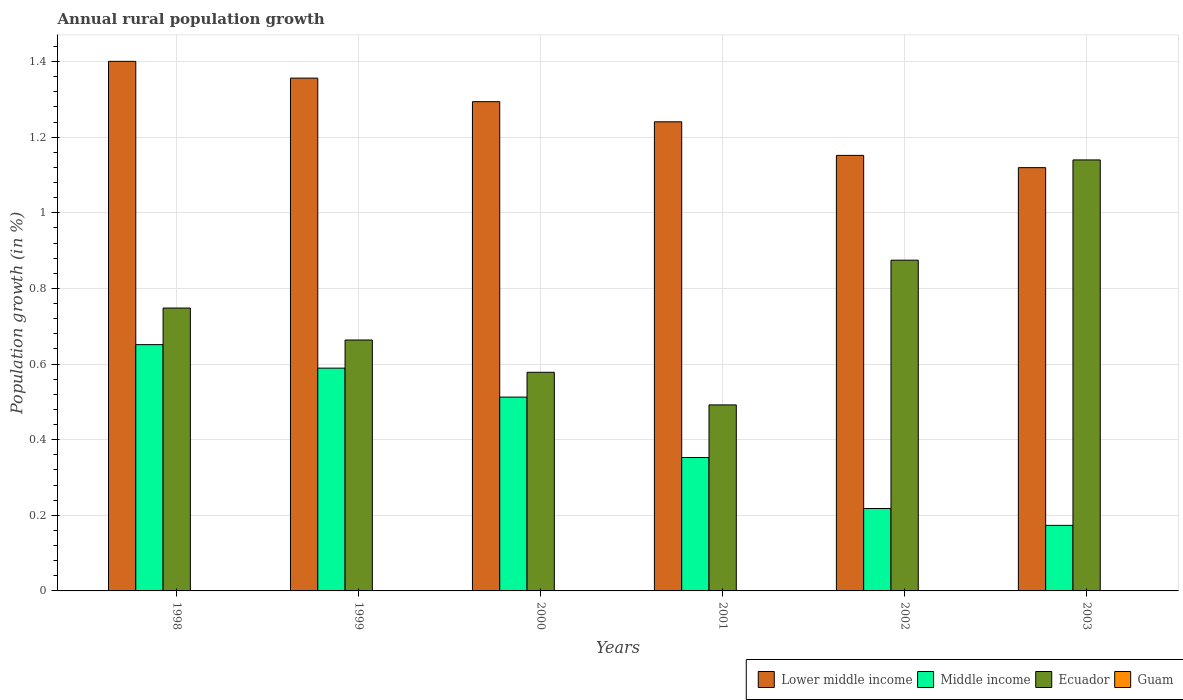How many groups of bars are there?
Ensure brevity in your answer.  6. How many bars are there on the 1st tick from the right?
Provide a short and direct response. 3. Across all years, what is the maximum percentage of rural population growth in Ecuador?
Ensure brevity in your answer.  1.14. Across all years, what is the minimum percentage of rural population growth in Middle income?
Your answer should be very brief. 0.17. In which year was the percentage of rural population growth in Middle income maximum?
Your answer should be very brief. 1998. What is the difference between the percentage of rural population growth in Ecuador in 1998 and that in 2000?
Offer a terse response. 0.17. What is the difference between the percentage of rural population growth in Lower middle income in 1998 and the percentage of rural population growth in Guam in 2001?
Your answer should be compact. 1.4. What is the average percentage of rural population growth in Guam per year?
Provide a short and direct response. 0. In the year 1999, what is the difference between the percentage of rural population growth in Lower middle income and percentage of rural population growth in Ecuador?
Your answer should be compact. 0.69. What is the ratio of the percentage of rural population growth in Ecuador in 1998 to that in 2002?
Provide a succinct answer. 0.86. What is the difference between the highest and the second highest percentage of rural population growth in Lower middle income?
Provide a short and direct response. 0.04. What is the difference between the highest and the lowest percentage of rural population growth in Middle income?
Provide a short and direct response. 0.48. In how many years, is the percentage of rural population growth in Lower middle income greater than the average percentage of rural population growth in Lower middle income taken over all years?
Your answer should be compact. 3. Is the sum of the percentage of rural population growth in Middle income in 1999 and 2002 greater than the maximum percentage of rural population growth in Guam across all years?
Provide a succinct answer. Yes. Is it the case that in every year, the sum of the percentage of rural population growth in Ecuador and percentage of rural population growth in Guam is greater than the sum of percentage of rural population growth in Lower middle income and percentage of rural population growth in Middle income?
Provide a succinct answer. No. Is it the case that in every year, the sum of the percentage of rural population growth in Guam and percentage of rural population growth in Middle income is greater than the percentage of rural population growth in Lower middle income?
Provide a short and direct response. No. Are all the bars in the graph horizontal?
Give a very brief answer. No. What is the difference between two consecutive major ticks on the Y-axis?
Give a very brief answer. 0.2. Where does the legend appear in the graph?
Your answer should be compact. Bottom right. How many legend labels are there?
Offer a very short reply. 4. What is the title of the graph?
Ensure brevity in your answer.  Annual rural population growth. Does "Virgin Islands" appear as one of the legend labels in the graph?
Offer a terse response. No. What is the label or title of the Y-axis?
Keep it short and to the point. Population growth (in %). What is the Population growth (in %) of Lower middle income in 1998?
Your answer should be compact. 1.4. What is the Population growth (in %) in Middle income in 1998?
Your answer should be very brief. 0.65. What is the Population growth (in %) in Ecuador in 1998?
Provide a short and direct response. 0.75. What is the Population growth (in %) of Lower middle income in 1999?
Offer a very short reply. 1.36. What is the Population growth (in %) of Middle income in 1999?
Your answer should be compact. 0.59. What is the Population growth (in %) in Ecuador in 1999?
Provide a succinct answer. 0.66. What is the Population growth (in %) of Guam in 1999?
Keep it short and to the point. 0. What is the Population growth (in %) of Lower middle income in 2000?
Give a very brief answer. 1.29. What is the Population growth (in %) in Middle income in 2000?
Give a very brief answer. 0.51. What is the Population growth (in %) in Ecuador in 2000?
Offer a terse response. 0.58. What is the Population growth (in %) of Lower middle income in 2001?
Your answer should be very brief. 1.24. What is the Population growth (in %) of Middle income in 2001?
Make the answer very short. 0.35. What is the Population growth (in %) of Ecuador in 2001?
Give a very brief answer. 0.49. What is the Population growth (in %) of Lower middle income in 2002?
Your answer should be compact. 1.15. What is the Population growth (in %) in Middle income in 2002?
Offer a very short reply. 0.22. What is the Population growth (in %) in Ecuador in 2002?
Make the answer very short. 0.87. What is the Population growth (in %) in Guam in 2002?
Make the answer very short. 0. What is the Population growth (in %) of Lower middle income in 2003?
Offer a terse response. 1.12. What is the Population growth (in %) in Middle income in 2003?
Ensure brevity in your answer.  0.17. What is the Population growth (in %) of Ecuador in 2003?
Provide a succinct answer. 1.14. Across all years, what is the maximum Population growth (in %) of Lower middle income?
Provide a short and direct response. 1.4. Across all years, what is the maximum Population growth (in %) in Middle income?
Provide a short and direct response. 0.65. Across all years, what is the maximum Population growth (in %) in Ecuador?
Make the answer very short. 1.14. Across all years, what is the minimum Population growth (in %) of Lower middle income?
Your response must be concise. 1.12. Across all years, what is the minimum Population growth (in %) in Middle income?
Offer a terse response. 0.17. Across all years, what is the minimum Population growth (in %) of Ecuador?
Your answer should be compact. 0.49. What is the total Population growth (in %) in Lower middle income in the graph?
Offer a terse response. 7.56. What is the total Population growth (in %) in Middle income in the graph?
Keep it short and to the point. 2.5. What is the total Population growth (in %) of Ecuador in the graph?
Offer a very short reply. 4.5. What is the total Population growth (in %) of Guam in the graph?
Offer a terse response. 0. What is the difference between the Population growth (in %) in Lower middle income in 1998 and that in 1999?
Ensure brevity in your answer.  0.04. What is the difference between the Population growth (in %) in Middle income in 1998 and that in 1999?
Your response must be concise. 0.06. What is the difference between the Population growth (in %) of Ecuador in 1998 and that in 1999?
Keep it short and to the point. 0.08. What is the difference between the Population growth (in %) of Lower middle income in 1998 and that in 2000?
Ensure brevity in your answer.  0.11. What is the difference between the Population growth (in %) of Middle income in 1998 and that in 2000?
Give a very brief answer. 0.14. What is the difference between the Population growth (in %) in Ecuador in 1998 and that in 2000?
Offer a terse response. 0.17. What is the difference between the Population growth (in %) of Lower middle income in 1998 and that in 2001?
Your response must be concise. 0.16. What is the difference between the Population growth (in %) in Middle income in 1998 and that in 2001?
Offer a terse response. 0.3. What is the difference between the Population growth (in %) in Ecuador in 1998 and that in 2001?
Your answer should be very brief. 0.26. What is the difference between the Population growth (in %) in Lower middle income in 1998 and that in 2002?
Give a very brief answer. 0.25. What is the difference between the Population growth (in %) in Middle income in 1998 and that in 2002?
Your response must be concise. 0.43. What is the difference between the Population growth (in %) in Ecuador in 1998 and that in 2002?
Keep it short and to the point. -0.13. What is the difference between the Population growth (in %) in Lower middle income in 1998 and that in 2003?
Offer a terse response. 0.28. What is the difference between the Population growth (in %) of Middle income in 1998 and that in 2003?
Your answer should be compact. 0.48. What is the difference between the Population growth (in %) of Ecuador in 1998 and that in 2003?
Your answer should be compact. -0.39. What is the difference between the Population growth (in %) of Lower middle income in 1999 and that in 2000?
Offer a terse response. 0.06. What is the difference between the Population growth (in %) of Middle income in 1999 and that in 2000?
Your response must be concise. 0.08. What is the difference between the Population growth (in %) in Ecuador in 1999 and that in 2000?
Give a very brief answer. 0.09. What is the difference between the Population growth (in %) of Lower middle income in 1999 and that in 2001?
Ensure brevity in your answer.  0.12. What is the difference between the Population growth (in %) in Middle income in 1999 and that in 2001?
Offer a terse response. 0.24. What is the difference between the Population growth (in %) of Ecuador in 1999 and that in 2001?
Offer a very short reply. 0.17. What is the difference between the Population growth (in %) of Lower middle income in 1999 and that in 2002?
Give a very brief answer. 0.2. What is the difference between the Population growth (in %) of Middle income in 1999 and that in 2002?
Offer a very short reply. 0.37. What is the difference between the Population growth (in %) in Ecuador in 1999 and that in 2002?
Offer a very short reply. -0.21. What is the difference between the Population growth (in %) in Lower middle income in 1999 and that in 2003?
Keep it short and to the point. 0.24. What is the difference between the Population growth (in %) of Middle income in 1999 and that in 2003?
Keep it short and to the point. 0.42. What is the difference between the Population growth (in %) of Ecuador in 1999 and that in 2003?
Keep it short and to the point. -0.48. What is the difference between the Population growth (in %) in Lower middle income in 2000 and that in 2001?
Your answer should be very brief. 0.05. What is the difference between the Population growth (in %) in Middle income in 2000 and that in 2001?
Provide a succinct answer. 0.16. What is the difference between the Population growth (in %) in Ecuador in 2000 and that in 2001?
Your answer should be compact. 0.09. What is the difference between the Population growth (in %) of Lower middle income in 2000 and that in 2002?
Your answer should be very brief. 0.14. What is the difference between the Population growth (in %) in Middle income in 2000 and that in 2002?
Make the answer very short. 0.29. What is the difference between the Population growth (in %) in Ecuador in 2000 and that in 2002?
Offer a terse response. -0.3. What is the difference between the Population growth (in %) in Lower middle income in 2000 and that in 2003?
Offer a terse response. 0.17. What is the difference between the Population growth (in %) of Middle income in 2000 and that in 2003?
Your response must be concise. 0.34. What is the difference between the Population growth (in %) of Ecuador in 2000 and that in 2003?
Make the answer very short. -0.56. What is the difference between the Population growth (in %) of Lower middle income in 2001 and that in 2002?
Make the answer very short. 0.09. What is the difference between the Population growth (in %) of Middle income in 2001 and that in 2002?
Your response must be concise. 0.14. What is the difference between the Population growth (in %) in Ecuador in 2001 and that in 2002?
Your answer should be compact. -0.38. What is the difference between the Population growth (in %) in Lower middle income in 2001 and that in 2003?
Offer a very short reply. 0.12. What is the difference between the Population growth (in %) in Middle income in 2001 and that in 2003?
Ensure brevity in your answer.  0.18. What is the difference between the Population growth (in %) in Ecuador in 2001 and that in 2003?
Offer a terse response. -0.65. What is the difference between the Population growth (in %) of Lower middle income in 2002 and that in 2003?
Offer a terse response. 0.03. What is the difference between the Population growth (in %) in Middle income in 2002 and that in 2003?
Your answer should be very brief. 0.04. What is the difference between the Population growth (in %) in Ecuador in 2002 and that in 2003?
Keep it short and to the point. -0.27. What is the difference between the Population growth (in %) of Lower middle income in 1998 and the Population growth (in %) of Middle income in 1999?
Make the answer very short. 0.81. What is the difference between the Population growth (in %) in Lower middle income in 1998 and the Population growth (in %) in Ecuador in 1999?
Ensure brevity in your answer.  0.74. What is the difference between the Population growth (in %) of Middle income in 1998 and the Population growth (in %) of Ecuador in 1999?
Your response must be concise. -0.01. What is the difference between the Population growth (in %) in Lower middle income in 1998 and the Population growth (in %) in Middle income in 2000?
Your response must be concise. 0.89. What is the difference between the Population growth (in %) in Lower middle income in 1998 and the Population growth (in %) in Ecuador in 2000?
Provide a short and direct response. 0.82. What is the difference between the Population growth (in %) of Middle income in 1998 and the Population growth (in %) of Ecuador in 2000?
Your response must be concise. 0.07. What is the difference between the Population growth (in %) in Lower middle income in 1998 and the Population growth (in %) in Middle income in 2001?
Keep it short and to the point. 1.05. What is the difference between the Population growth (in %) in Lower middle income in 1998 and the Population growth (in %) in Ecuador in 2001?
Your answer should be compact. 0.91. What is the difference between the Population growth (in %) of Middle income in 1998 and the Population growth (in %) of Ecuador in 2001?
Offer a terse response. 0.16. What is the difference between the Population growth (in %) in Lower middle income in 1998 and the Population growth (in %) in Middle income in 2002?
Provide a succinct answer. 1.18. What is the difference between the Population growth (in %) in Lower middle income in 1998 and the Population growth (in %) in Ecuador in 2002?
Your response must be concise. 0.53. What is the difference between the Population growth (in %) of Middle income in 1998 and the Population growth (in %) of Ecuador in 2002?
Provide a short and direct response. -0.22. What is the difference between the Population growth (in %) of Lower middle income in 1998 and the Population growth (in %) of Middle income in 2003?
Offer a terse response. 1.23. What is the difference between the Population growth (in %) of Lower middle income in 1998 and the Population growth (in %) of Ecuador in 2003?
Your answer should be compact. 0.26. What is the difference between the Population growth (in %) of Middle income in 1998 and the Population growth (in %) of Ecuador in 2003?
Provide a succinct answer. -0.49. What is the difference between the Population growth (in %) of Lower middle income in 1999 and the Population growth (in %) of Middle income in 2000?
Make the answer very short. 0.84. What is the difference between the Population growth (in %) in Lower middle income in 1999 and the Population growth (in %) in Ecuador in 2000?
Provide a succinct answer. 0.78. What is the difference between the Population growth (in %) in Middle income in 1999 and the Population growth (in %) in Ecuador in 2000?
Your answer should be very brief. 0.01. What is the difference between the Population growth (in %) of Lower middle income in 1999 and the Population growth (in %) of Middle income in 2001?
Offer a very short reply. 1. What is the difference between the Population growth (in %) in Lower middle income in 1999 and the Population growth (in %) in Ecuador in 2001?
Offer a very short reply. 0.86. What is the difference between the Population growth (in %) in Middle income in 1999 and the Population growth (in %) in Ecuador in 2001?
Make the answer very short. 0.1. What is the difference between the Population growth (in %) of Lower middle income in 1999 and the Population growth (in %) of Middle income in 2002?
Give a very brief answer. 1.14. What is the difference between the Population growth (in %) of Lower middle income in 1999 and the Population growth (in %) of Ecuador in 2002?
Provide a succinct answer. 0.48. What is the difference between the Population growth (in %) of Middle income in 1999 and the Population growth (in %) of Ecuador in 2002?
Keep it short and to the point. -0.29. What is the difference between the Population growth (in %) of Lower middle income in 1999 and the Population growth (in %) of Middle income in 2003?
Provide a short and direct response. 1.18. What is the difference between the Population growth (in %) in Lower middle income in 1999 and the Population growth (in %) in Ecuador in 2003?
Your response must be concise. 0.22. What is the difference between the Population growth (in %) in Middle income in 1999 and the Population growth (in %) in Ecuador in 2003?
Your answer should be compact. -0.55. What is the difference between the Population growth (in %) of Lower middle income in 2000 and the Population growth (in %) of Ecuador in 2001?
Your response must be concise. 0.8. What is the difference between the Population growth (in %) in Middle income in 2000 and the Population growth (in %) in Ecuador in 2001?
Provide a succinct answer. 0.02. What is the difference between the Population growth (in %) of Lower middle income in 2000 and the Population growth (in %) of Middle income in 2002?
Keep it short and to the point. 1.08. What is the difference between the Population growth (in %) of Lower middle income in 2000 and the Population growth (in %) of Ecuador in 2002?
Provide a short and direct response. 0.42. What is the difference between the Population growth (in %) of Middle income in 2000 and the Population growth (in %) of Ecuador in 2002?
Your answer should be compact. -0.36. What is the difference between the Population growth (in %) in Lower middle income in 2000 and the Population growth (in %) in Middle income in 2003?
Provide a short and direct response. 1.12. What is the difference between the Population growth (in %) in Lower middle income in 2000 and the Population growth (in %) in Ecuador in 2003?
Keep it short and to the point. 0.15. What is the difference between the Population growth (in %) of Middle income in 2000 and the Population growth (in %) of Ecuador in 2003?
Your answer should be very brief. -0.63. What is the difference between the Population growth (in %) of Lower middle income in 2001 and the Population growth (in %) of Middle income in 2002?
Your answer should be very brief. 1.02. What is the difference between the Population growth (in %) in Lower middle income in 2001 and the Population growth (in %) in Ecuador in 2002?
Keep it short and to the point. 0.37. What is the difference between the Population growth (in %) in Middle income in 2001 and the Population growth (in %) in Ecuador in 2002?
Your answer should be very brief. -0.52. What is the difference between the Population growth (in %) in Lower middle income in 2001 and the Population growth (in %) in Middle income in 2003?
Offer a very short reply. 1.07. What is the difference between the Population growth (in %) in Lower middle income in 2001 and the Population growth (in %) in Ecuador in 2003?
Offer a terse response. 0.1. What is the difference between the Population growth (in %) in Middle income in 2001 and the Population growth (in %) in Ecuador in 2003?
Provide a succinct answer. -0.79. What is the difference between the Population growth (in %) in Lower middle income in 2002 and the Population growth (in %) in Middle income in 2003?
Give a very brief answer. 0.98. What is the difference between the Population growth (in %) in Lower middle income in 2002 and the Population growth (in %) in Ecuador in 2003?
Your response must be concise. 0.01. What is the difference between the Population growth (in %) of Middle income in 2002 and the Population growth (in %) of Ecuador in 2003?
Your answer should be compact. -0.92. What is the average Population growth (in %) of Lower middle income per year?
Your answer should be compact. 1.26. What is the average Population growth (in %) in Middle income per year?
Provide a short and direct response. 0.42. What is the average Population growth (in %) in Ecuador per year?
Make the answer very short. 0.75. What is the average Population growth (in %) in Guam per year?
Make the answer very short. 0. In the year 1998, what is the difference between the Population growth (in %) of Lower middle income and Population growth (in %) of Middle income?
Your response must be concise. 0.75. In the year 1998, what is the difference between the Population growth (in %) of Lower middle income and Population growth (in %) of Ecuador?
Keep it short and to the point. 0.65. In the year 1998, what is the difference between the Population growth (in %) of Middle income and Population growth (in %) of Ecuador?
Your response must be concise. -0.1. In the year 1999, what is the difference between the Population growth (in %) of Lower middle income and Population growth (in %) of Middle income?
Your response must be concise. 0.77. In the year 1999, what is the difference between the Population growth (in %) of Lower middle income and Population growth (in %) of Ecuador?
Offer a terse response. 0.69. In the year 1999, what is the difference between the Population growth (in %) in Middle income and Population growth (in %) in Ecuador?
Ensure brevity in your answer.  -0.07. In the year 2000, what is the difference between the Population growth (in %) of Lower middle income and Population growth (in %) of Middle income?
Ensure brevity in your answer.  0.78. In the year 2000, what is the difference between the Population growth (in %) in Lower middle income and Population growth (in %) in Ecuador?
Your response must be concise. 0.72. In the year 2000, what is the difference between the Population growth (in %) in Middle income and Population growth (in %) in Ecuador?
Your answer should be very brief. -0.07. In the year 2001, what is the difference between the Population growth (in %) in Lower middle income and Population growth (in %) in Middle income?
Provide a succinct answer. 0.89. In the year 2001, what is the difference between the Population growth (in %) of Lower middle income and Population growth (in %) of Ecuador?
Your answer should be compact. 0.75. In the year 2001, what is the difference between the Population growth (in %) in Middle income and Population growth (in %) in Ecuador?
Offer a very short reply. -0.14. In the year 2002, what is the difference between the Population growth (in %) of Lower middle income and Population growth (in %) of Middle income?
Your response must be concise. 0.93. In the year 2002, what is the difference between the Population growth (in %) of Lower middle income and Population growth (in %) of Ecuador?
Provide a short and direct response. 0.28. In the year 2002, what is the difference between the Population growth (in %) of Middle income and Population growth (in %) of Ecuador?
Provide a short and direct response. -0.66. In the year 2003, what is the difference between the Population growth (in %) in Lower middle income and Population growth (in %) in Middle income?
Provide a succinct answer. 0.95. In the year 2003, what is the difference between the Population growth (in %) in Lower middle income and Population growth (in %) in Ecuador?
Offer a terse response. -0.02. In the year 2003, what is the difference between the Population growth (in %) of Middle income and Population growth (in %) of Ecuador?
Provide a succinct answer. -0.97. What is the ratio of the Population growth (in %) in Lower middle income in 1998 to that in 1999?
Your answer should be compact. 1.03. What is the ratio of the Population growth (in %) in Middle income in 1998 to that in 1999?
Make the answer very short. 1.11. What is the ratio of the Population growth (in %) of Ecuador in 1998 to that in 1999?
Give a very brief answer. 1.13. What is the ratio of the Population growth (in %) in Lower middle income in 1998 to that in 2000?
Your response must be concise. 1.08. What is the ratio of the Population growth (in %) in Middle income in 1998 to that in 2000?
Keep it short and to the point. 1.27. What is the ratio of the Population growth (in %) of Ecuador in 1998 to that in 2000?
Provide a succinct answer. 1.29. What is the ratio of the Population growth (in %) of Lower middle income in 1998 to that in 2001?
Your answer should be very brief. 1.13. What is the ratio of the Population growth (in %) of Middle income in 1998 to that in 2001?
Provide a short and direct response. 1.85. What is the ratio of the Population growth (in %) in Ecuador in 1998 to that in 2001?
Give a very brief answer. 1.52. What is the ratio of the Population growth (in %) of Lower middle income in 1998 to that in 2002?
Your answer should be compact. 1.22. What is the ratio of the Population growth (in %) in Middle income in 1998 to that in 2002?
Provide a succinct answer. 2.99. What is the ratio of the Population growth (in %) in Ecuador in 1998 to that in 2002?
Provide a succinct answer. 0.86. What is the ratio of the Population growth (in %) in Lower middle income in 1998 to that in 2003?
Your answer should be very brief. 1.25. What is the ratio of the Population growth (in %) of Middle income in 1998 to that in 2003?
Ensure brevity in your answer.  3.76. What is the ratio of the Population growth (in %) of Ecuador in 1998 to that in 2003?
Make the answer very short. 0.66. What is the ratio of the Population growth (in %) of Lower middle income in 1999 to that in 2000?
Give a very brief answer. 1.05. What is the ratio of the Population growth (in %) in Middle income in 1999 to that in 2000?
Your answer should be compact. 1.15. What is the ratio of the Population growth (in %) of Ecuador in 1999 to that in 2000?
Give a very brief answer. 1.15. What is the ratio of the Population growth (in %) of Lower middle income in 1999 to that in 2001?
Make the answer very short. 1.09. What is the ratio of the Population growth (in %) of Middle income in 1999 to that in 2001?
Make the answer very short. 1.67. What is the ratio of the Population growth (in %) of Ecuador in 1999 to that in 2001?
Give a very brief answer. 1.35. What is the ratio of the Population growth (in %) of Lower middle income in 1999 to that in 2002?
Ensure brevity in your answer.  1.18. What is the ratio of the Population growth (in %) of Middle income in 1999 to that in 2002?
Ensure brevity in your answer.  2.7. What is the ratio of the Population growth (in %) in Ecuador in 1999 to that in 2002?
Keep it short and to the point. 0.76. What is the ratio of the Population growth (in %) in Lower middle income in 1999 to that in 2003?
Your response must be concise. 1.21. What is the ratio of the Population growth (in %) of Middle income in 1999 to that in 2003?
Offer a very short reply. 3.4. What is the ratio of the Population growth (in %) of Ecuador in 1999 to that in 2003?
Offer a very short reply. 0.58. What is the ratio of the Population growth (in %) in Lower middle income in 2000 to that in 2001?
Keep it short and to the point. 1.04. What is the ratio of the Population growth (in %) in Middle income in 2000 to that in 2001?
Offer a very short reply. 1.45. What is the ratio of the Population growth (in %) in Ecuador in 2000 to that in 2001?
Keep it short and to the point. 1.18. What is the ratio of the Population growth (in %) of Lower middle income in 2000 to that in 2002?
Provide a short and direct response. 1.12. What is the ratio of the Population growth (in %) in Middle income in 2000 to that in 2002?
Give a very brief answer. 2.35. What is the ratio of the Population growth (in %) of Ecuador in 2000 to that in 2002?
Offer a terse response. 0.66. What is the ratio of the Population growth (in %) of Lower middle income in 2000 to that in 2003?
Give a very brief answer. 1.16. What is the ratio of the Population growth (in %) of Middle income in 2000 to that in 2003?
Your answer should be very brief. 2.96. What is the ratio of the Population growth (in %) of Ecuador in 2000 to that in 2003?
Give a very brief answer. 0.51. What is the ratio of the Population growth (in %) in Lower middle income in 2001 to that in 2002?
Your answer should be very brief. 1.08. What is the ratio of the Population growth (in %) of Middle income in 2001 to that in 2002?
Give a very brief answer. 1.62. What is the ratio of the Population growth (in %) in Ecuador in 2001 to that in 2002?
Give a very brief answer. 0.56. What is the ratio of the Population growth (in %) of Lower middle income in 2001 to that in 2003?
Provide a short and direct response. 1.11. What is the ratio of the Population growth (in %) in Middle income in 2001 to that in 2003?
Make the answer very short. 2.04. What is the ratio of the Population growth (in %) of Ecuador in 2001 to that in 2003?
Offer a terse response. 0.43. What is the ratio of the Population growth (in %) in Lower middle income in 2002 to that in 2003?
Provide a succinct answer. 1.03. What is the ratio of the Population growth (in %) of Middle income in 2002 to that in 2003?
Keep it short and to the point. 1.26. What is the ratio of the Population growth (in %) of Ecuador in 2002 to that in 2003?
Your answer should be very brief. 0.77. What is the difference between the highest and the second highest Population growth (in %) of Lower middle income?
Make the answer very short. 0.04. What is the difference between the highest and the second highest Population growth (in %) of Middle income?
Offer a very short reply. 0.06. What is the difference between the highest and the second highest Population growth (in %) of Ecuador?
Offer a terse response. 0.27. What is the difference between the highest and the lowest Population growth (in %) of Lower middle income?
Your answer should be very brief. 0.28. What is the difference between the highest and the lowest Population growth (in %) of Middle income?
Your answer should be very brief. 0.48. What is the difference between the highest and the lowest Population growth (in %) of Ecuador?
Provide a short and direct response. 0.65. 